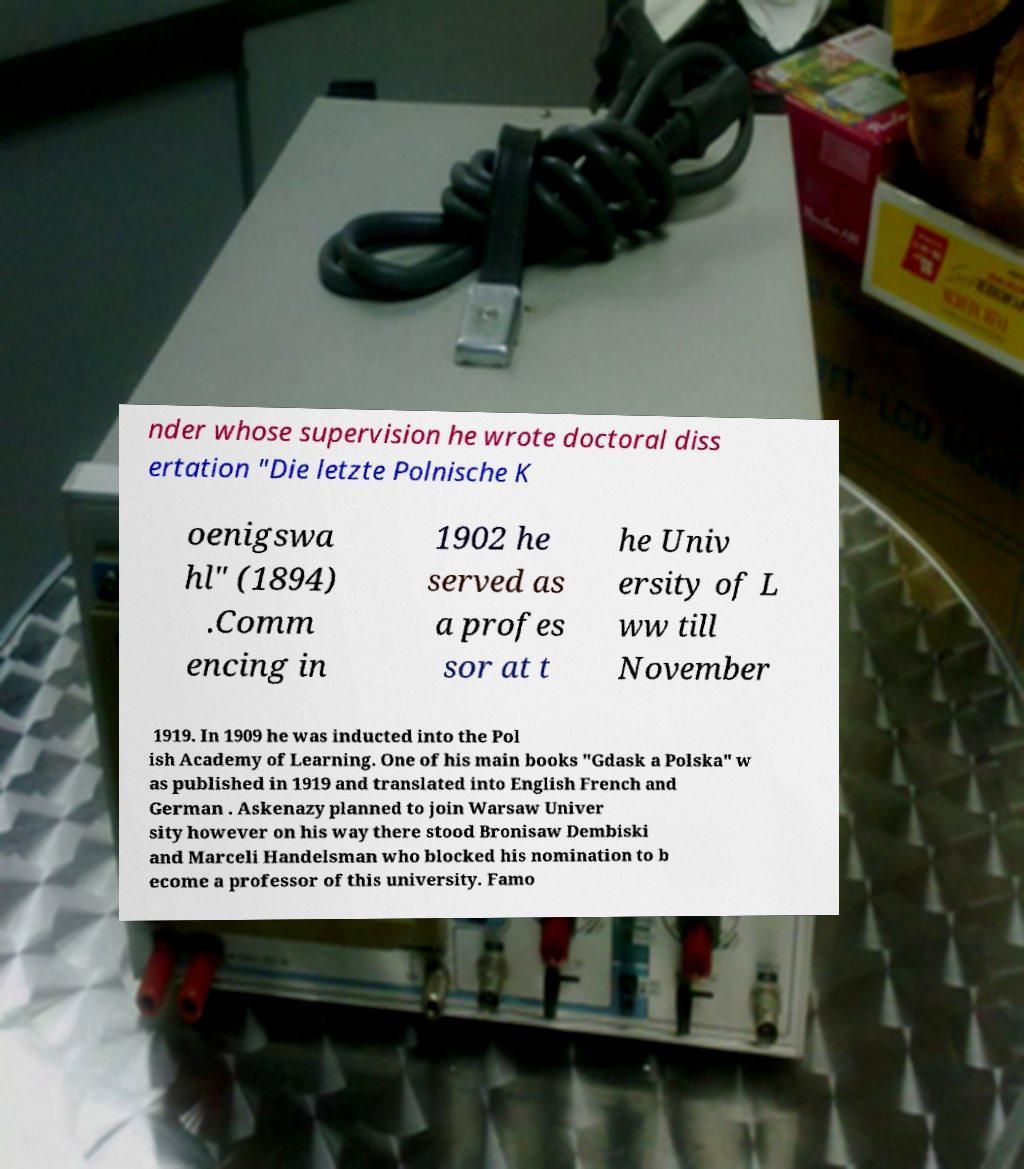Please identify and transcribe the text found in this image. nder whose supervision he wrote doctoral diss ertation "Die letzte Polnische K oenigswa hl" (1894) .Comm encing in 1902 he served as a profes sor at t he Univ ersity of L ww till November 1919. In 1909 he was inducted into the Pol ish Academy of Learning. One of his main books "Gdask a Polska" w as published in 1919 and translated into English French and German . Askenazy planned to join Warsaw Univer sity however on his way there stood Bronisaw Dembiski and Marceli Handelsman who blocked his nomination to b ecome a professor of this university. Famo 